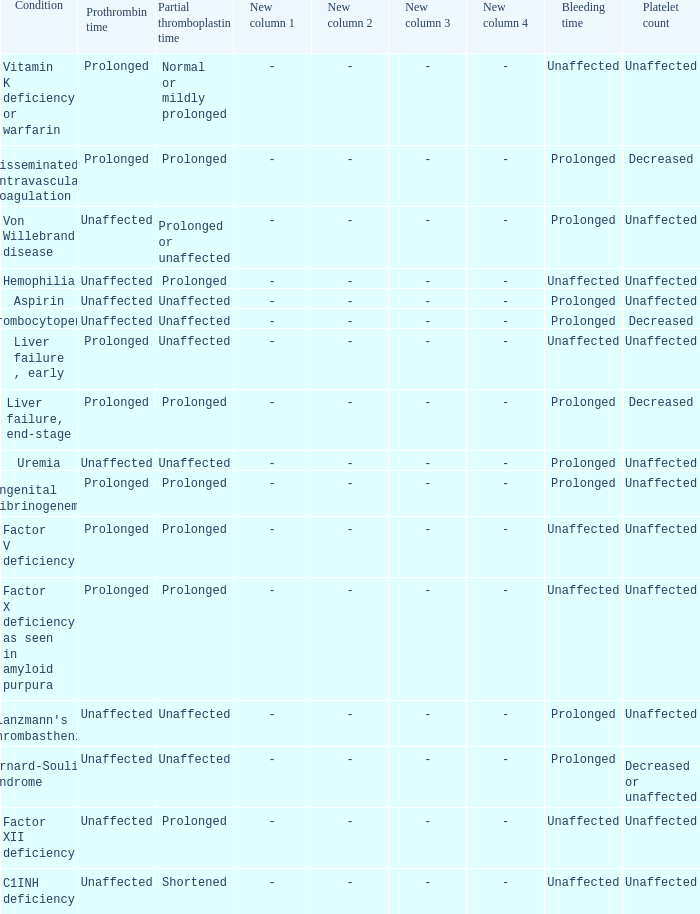Which Condition has an unaffected Partial thromboplastin time, Platelet count, and a Prothrombin time? Aspirin, Uremia, Glanzmann's thrombasthenia. 